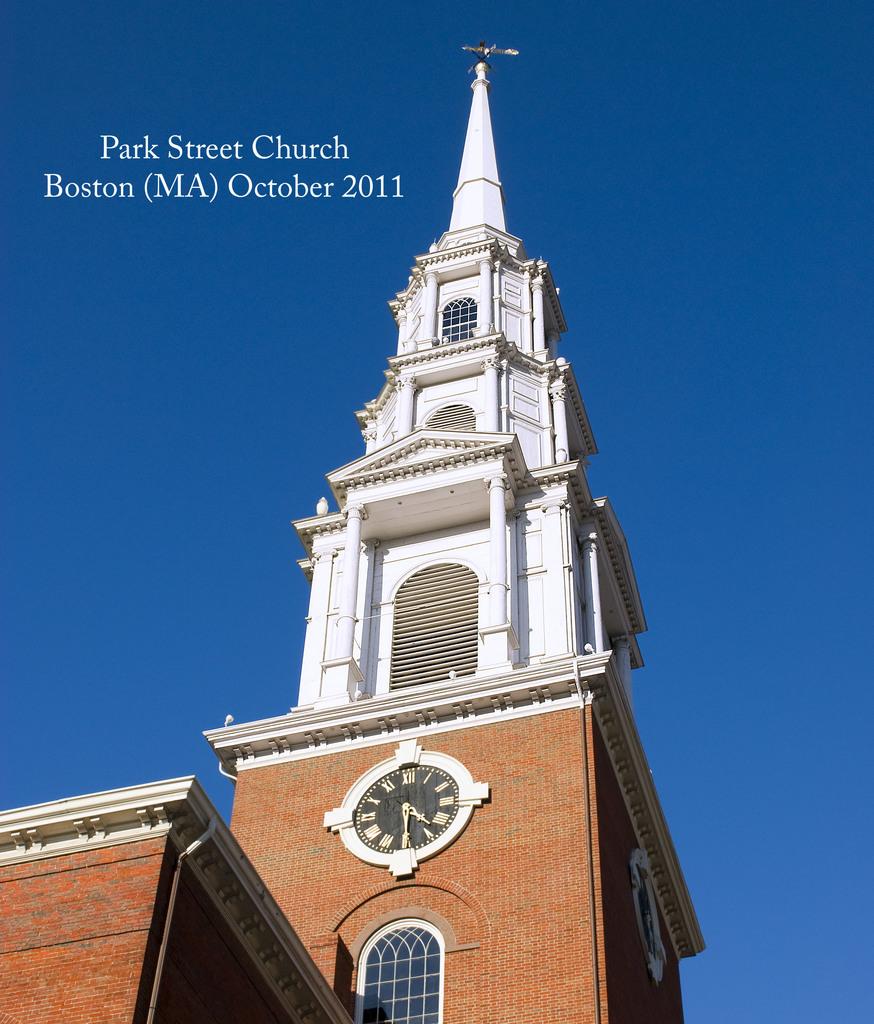What street is the church on?
Your response must be concise. Park street. What town is this church in?
Provide a short and direct response. Boston. 